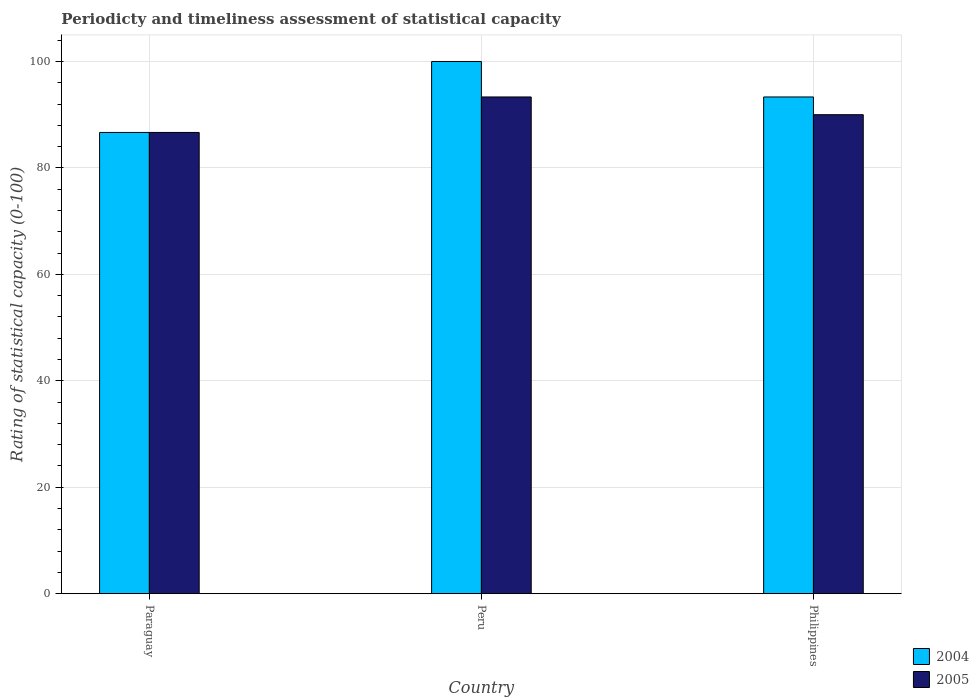In how many cases, is the number of bars for a given country not equal to the number of legend labels?
Your answer should be very brief. 0. What is the rating of statistical capacity in 2004 in Philippines?
Your answer should be compact. 93.33. Across all countries, what is the maximum rating of statistical capacity in 2005?
Give a very brief answer. 93.33. Across all countries, what is the minimum rating of statistical capacity in 2005?
Ensure brevity in your answer.  86.67. In which country was the rating of statistical capacity in 2005 maximum?
Offer a terse response. Peru. In which country was the rating of statistical capacity in 2005 minimum?
Offer a terse response. Paraguay. What is the total rating of statistical capacity in 2005 in the graph?
Keep it short and to the point. 270. What is the difference between the rating of statistical capacity in 2004 in Paraguay and that in Philippines?
Your answer should be very brief. -6.67. What is the average rating of statistical capacity in 2005 per country?
Keep it short and to the point. 90. In how many countries, is the rating of statistical capacity in 2005 greater than 52?
Your answer should be very brief. 3. What is the ratio of the rating of statistical capacity in 2004 in Paraguay to that in Philippines?
Provide a succinct answer. 0.93. Is the rating of statistical capacity in 2005 in Paraguay less than that in Philippines?
Your answer should be very brief. Yes. What is the difference between the highest and the second highest rating of statistical capacity in 2005?
Offer a very short reply. -3.33. What is the difference between the highest and the lowest rating of statistical capacity in 2005?
Keep it short and to the point. 6.67. Is the sum of the rating of statistical capacity in 2005 in Paraguay and Peru greater than the maximum rating of statistical capacity in 2004 across all countries?
Your answer should be very brief. Yes. What does the 2nd bar from the left in Peru represents?
Provide a short and direct response. 2005. Are all the bars in the graph horizontal?
Your response must be concise. No. Are the values on the major ticks of Y-axis written in scientific E-notation?
Give a very brief answer. No. Does the graph contain any zero values?
Provide a short and direct response. No. Does the graph contain grids?
Keep it short and to the point. Yes. Where does the legend appear in the graph?
Make the answer very short. Bottom right. What is the title of the graph?
Keep it short and to the point. Periodicty and timeliness assessment of statistical capacity. What is the label or title of the X-axis?
Offer a terse response. Country. What is the label or title of the Y-axis?
Offer a very short reply. Rating of statistical capacity (0-100). What is the Rating of statistical capacity (0-100) of 2004 in Paraguay?
Give a very brief answer. 86.67. What is the Rating of statistical capacity (0-100) in 2005 in Paraguay?
Your response must be concise. 86.67. What is the Rating of statistical capacity (0-100) of 2005 in Peru?
Provide a succinct answer. 93.33. What is the Rating of statistical capacity (0-100) in 2004 in Philippines?
Provide a short and direct response. 93.33. What is the Rating of statistical capacity (0-100) in 2005 in Philippines?
Your answer should be very brief. 90. Across all countries, what is the maximum Rating of statistical capacity (0-100) of 2004?
Provide a short and direct response. 100. Across all countries, what is the maximum Rating of statistical capacity (0-100) in 2005?
Provide a succinct answer. 93.33. Across all countries, what is the minimum Rating of statistical capacity (0-100) in 2004?
Ensure brevity in your answer.  86.67. Across all countries, what is the minimum Rating of statistical capacity (0-100) in 2005?
Your answer should be very brief. 86.67. What is the total Rating of statistical capacity (0-100) in 2004 in the graph?
Your response must be concise. 280. What is the total Rating of statistical capacity (0-100) in 2005 in the graph?
Give a very brief answer. 270. What is the difference between the Rating of statistical capacity (0-100) of 2004 in Paraguay and that in Peru?
Your answer should be very brief. -13.33. What is the difference between the Rating of statistical capacity (0-100) in 2005 in Paraguay and that in Peru?
Provide a short and direct response. -6.67. What is the difference between the Rating of statistical capacity (0-100) of 2004 in Paraguay and that in Philippines?
Your answer should be compact. -6.67. What is the difference between the Rating of statistical capacity (0-100) of 2005 in Peru and that in Philippines?
Your answer should be very brief. 3.33. What is the difference between the Rating of statistical capacity (0-100) of 2004 in Paraguay and the Rating of statistical capacity (0-100) of 2005 in Peru?
Your answer should be compact. -6.67. What is the difference between the Rating of statistical capacity (0-100) in 2004 in Peru and the Rating of statistical capacity (0-100) in 2005 in Philippines?
Make the answer very short. 10. What is the average Rating of statistical capacity (0-100) of 2004 per country?
Provide a short and direct response. 93.33. What is the average Rating of statistical capacity (0-100) in 2005 per country?
Make the answer very short. 90. What is the ratio of the Rating of statistical capacity (0-100) in 2004 in Paraguay to that in Peru?
Provide a succinct answer. 0.87. What is the ratio of the Rating of statistical capacity (0-100) of 2005 in Paraguay to that in Peru?
Your answer should be compact. 0.93. What is the ratio of the Rating of statistical capacity (0-100) in 2004 in Peru to that in Philippines?
Keep it short and to the point. 1.07. What is the ratio of the Rating of statistical capacity (0-100) of 2005 in Peru to that in Philippines?
Offer a terse response. 1.04. What is the difference between the highest and the second highest Rating of statistical capacity (0-100) in 2005?
Provide a short and direct response. 3.33. What is the difference between the highest and the lowest Rating of statistical capacity (0-100) of 2004?
Your answer should be compact. 13.33. What is the difference between the highest and the lowest Rating of statistical capacity (0-100) in 2005?
Your answer should be very brief. 6.67. 